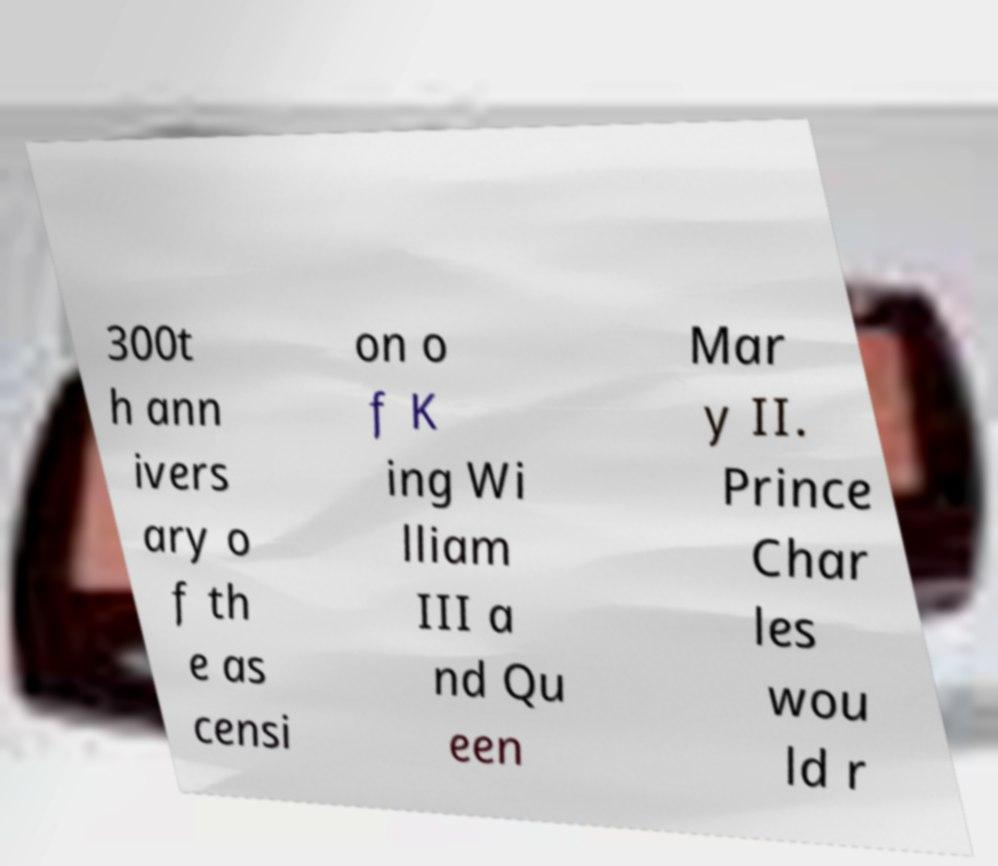Could you extract and type out the text from this image? 300t h ann ivers ary o f th e as censi on o f K ing Wi lliam III a nd Qu een Mar y II. Prince Char les wou ld r 